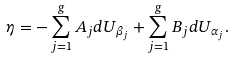Convert formula to latex. <formula><loc_0><loc_0><loc_500><loc_500>\eta = - \sum _ { j = 1 } ^ { g } A _ { j } d U _ { \beta _ { j } } + \sum _ { j = 1 } ^ { g } B _ { j } d U _ { \alpha _ { j } } .</formula> 